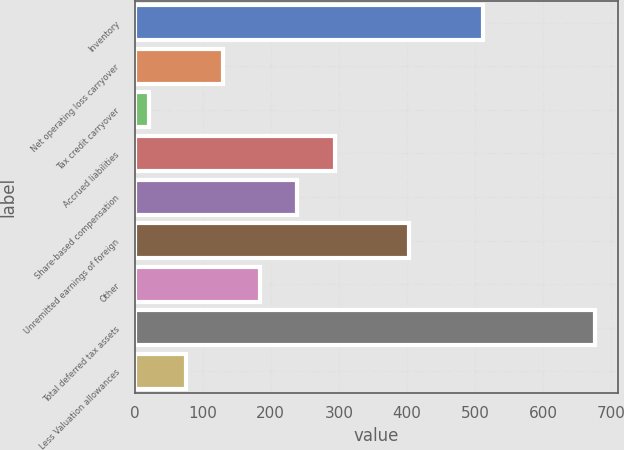<chart> <loc_0><loc_0><loc_500><loc_500><bar_chart><fcel>Inventory<fcel>Net operating loss carryover<fcel>Tax credit carryover<fcel>Accrued liabilities<fcel>Share-based compensation<fcel>Unremitted earnings of foreign<fcel>Other<fcel>Total deferred tax assets<fcel>Less Valuation allowances<nl><fcel>512.46<fcel>129.98<fcel>20.7<fcel>293.9<fcel>239.26<fcel>403.18<fcel>184.62<fcel>676.38<fcel>75.34<nl></chart> 